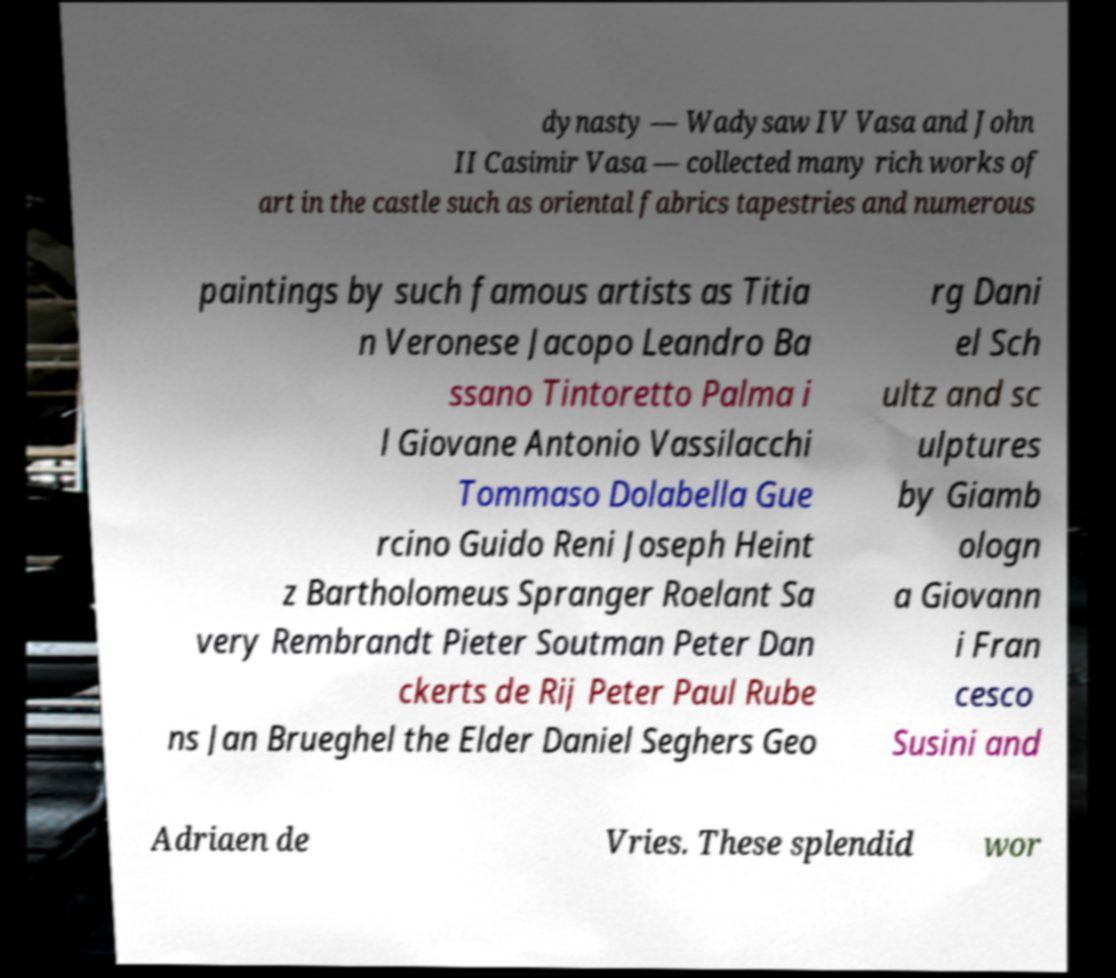Can you read and provide the text displayed in the image?This photo seems to have some interesting text. Can you extract and type it out for me? dynasty — Wadysaw IV Vasa and John II Casimir Vasa — collected many rich works of art in the castle such as oriental fabrics tapestries and numerous paintings by such famous artists as Titia n Veronese Jacopo Leandro Ba ssano Tintoretto Palma i l Giovane Antonio Vassilacchi Tommaso Dolabella Gue rcino Guido Reni Joseph Heint z Bartholomeus Spranger Roelant Sa very Rembrandt Pieter Soutman Peter Dan ckerts de Rij Peter Paul Rube ns Jan Brueghel the Elder Daniel Seghers Geo rg Dani el Sch ultz and sc ulptures by Giamb ologn a Giovann i Fran cesco Susini and Adriaen de Vries. These splendid wor 